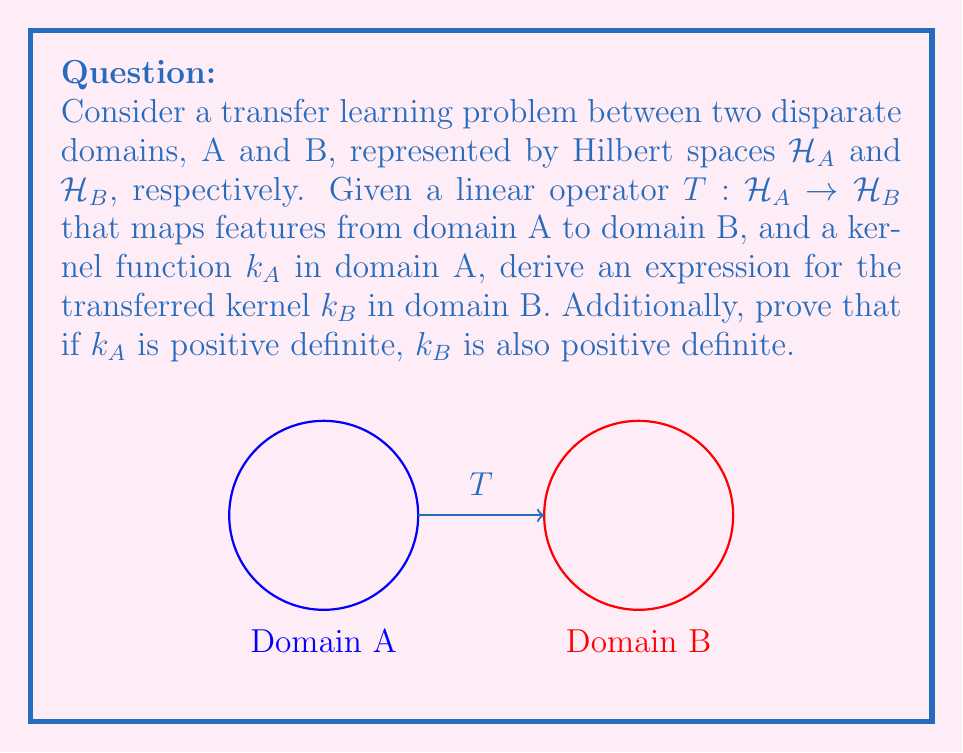What is the answer to this math problem? Let's approach this problem step-by-step:

1) First, recall that a kernel function $k_A$ in domain A can be expressed as an inner product in the feature space:

   $k_A(x, y) = \langle \phi_A(x), \phi_A(y) \rangle_{\mathcal{H}_A}$

   where $\phi_A$ is the feature map for domain A.

2) The linear operator $T$ maps features from $\mathcal{H}_A$ to $\mathcal{H}_B$. So, for any $x$ in domain A:

   $T(\phi_A(x)) \in \mathcal{H}_B$

3) We can define the transferred kernel $k_B$ using $T$ as follows:

   $k_B(x, y) = \langle T(\phi_A(x)), T(\phi_A(y)) \rangle_{\mathcal{H}_B}$

4) Using the properties of inner products and linear operators, we can rewrite this as:

   $k_B(x, y) = \langle \phi_A(x), T^*T(\phi_A(y)) \rangle_{\mathcal{H}_A}$

   where $T^*$ is the adjoint operator of $T$.

5) Now, let's prove that $k_B$ is positive definite if $k_A$ is positive definite.

6) A kernel is positive definite if for any finite set of points $\{x_1, ..., x_n\}$ and any real numbers $\{c_1, ..., c_n\}$, we have:

   $\sum_{i=1}^n \sum_{j=1}^n c_i c_j k(x_i, x_j) \geq 0$

7) For $k_B$, we need to show:

   $\sum_{i=1}^n \sum_{j=1}^n c_i c_j k_B(x_i, x_j) \geq 0$

8) Substituting the expression for $k_B$:

   $\sum_{i=1}^n \sum_{j=1}^n c_i c_j \langle T(\phi_A(x_i)), T(\phi_A(x_j)) \rangle_{\mathcal{H}_B} \geq 0$

9) This is equivalent to:

   $\left\langle \sum_{i=1}^n c_i T(\phi_A(x_i)), \sum_{j=1}^n c_j T(\phi_A(x_j)) \right\rangle_{\mathcal{H}_B} \geq 0$

10) The inner product is always non-negative, so $k_B$ is positive definite.
Answer: $k_B(x, y) = \langle T(\phi_A(x)), T(\phi_A(y)) \rangle_{\mathcal{H}_B} = \langle \phi_A(x), T^*T(\phi_A(y)) \rangle_{\mathcal{H}_A}$ 